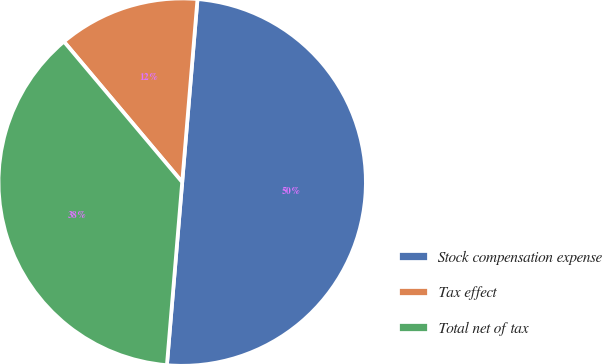Convert chart to OTSL. <chart><loc_0><loc_0><loc_500><loc_500><pie_chart><fcel>Stock compensation expense<fcel>Tax effect<fcel>Total net of tax<nl><fcel>50.0%<fcel>12.46%<fcel>37.54%<nl></chart> 